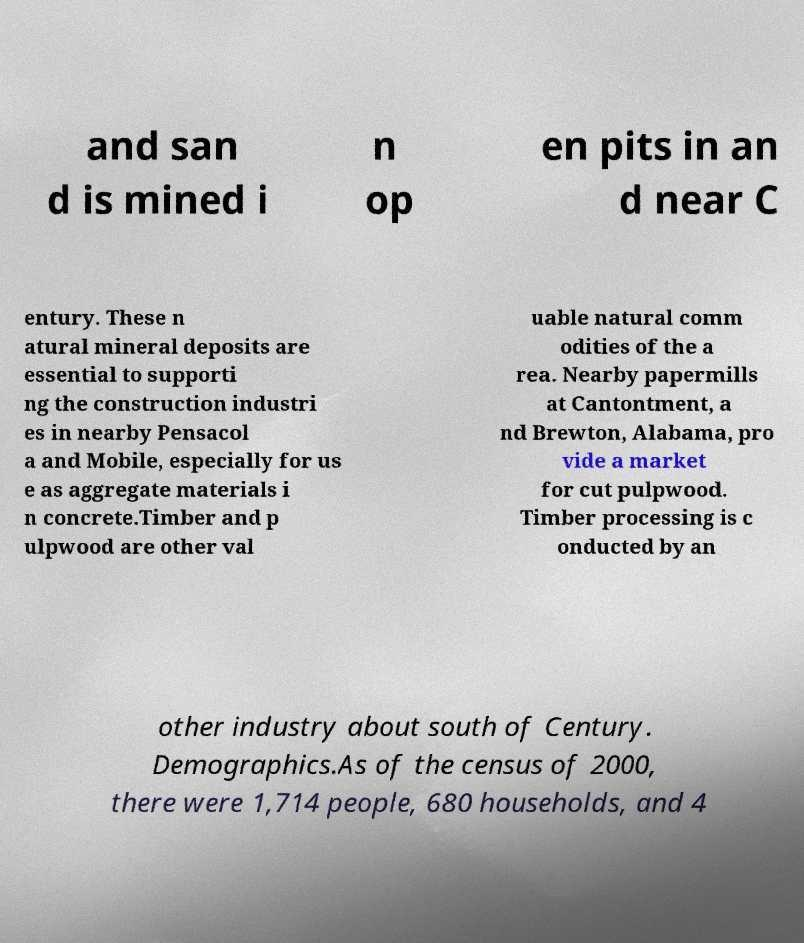Can you accurately transcribe the text from the provided image for me? and san d is mined i n op en pits in an d near C entury. These n atural mineral deposits are essential to supporti ng the construction industri es in nearby Pensacol a and Mobile, especially for us e as aggregate materials i n concrete.Timber and p ulpwood are other val uable natural comm odities of the a rea. Nearby papermills at Cantontment, a nd Brewton, Alabama, pro vide a market for cut pulpwood. Timber processing is c onducted by an other industry about south of Century. Demographics.As of the census of 2000, there were 1,714 people, 680 households, and 4 